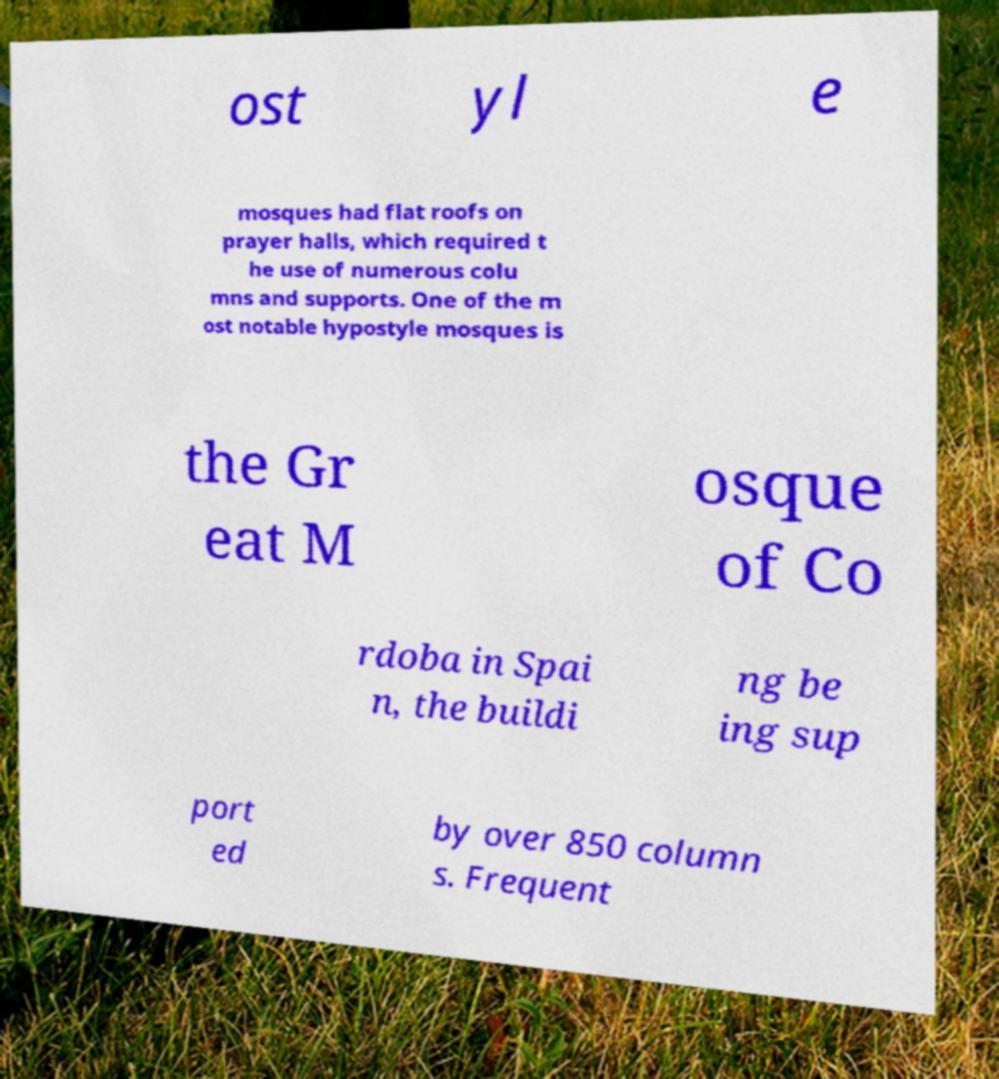Could you extract and type out the text from this image? ost yl e mosques had flat roofs on prayer halls, which required t he use of numerous colu mns and supports. One of the m ost notable hypostyle mosques is the Gr eat M osque of Co rdoba in Spai n, the buildi ng be ing sup port ed by over 850 column s. Frequent 